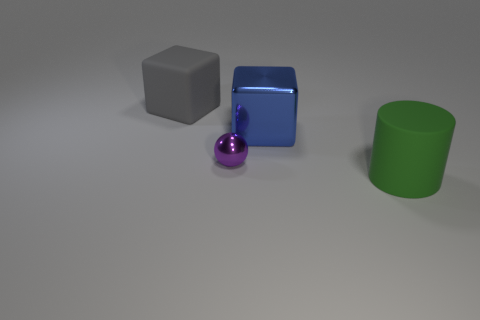There is a large matte object on the right side of the large rubber thing behind the tiny metal object; what number of rubber cylinders are behind it?
Keep it short and to the point. 0. There is a object that is behind the small purple ball and on the left side of the blue thing; what material is it?
Offer a terse response. Rubber. The large rubber cylinder is what color?
Give a very brief answer. Green. Are there more green matte things that are to the right of the small sphere than spheres on the right side of the green thing?
Give a very brief answer. Yes. What is the color of the matte thing behind the small purple metallic object?
Your answer should be compact. Gray. There is a rubber thing behind the green cylinder; is its size the same as the matte object that is right of the big shiny cube?
Your answer should be compact. Yes. How many objects are either tiny cyan metal objects or cubes?
Keep it short and to the point. 2. What material is the large block that is to the right of the cube that is behind the blue thing made of?
Your answer should be compact. Metal. What number of blue objects are the same shape as the gray matte object?
Give a very brief answer. 1. How many things are big gray objects on the left side of the purple metallic sphere or matte things in front of the big metal cube?
Provide a short and direct response. 2. 